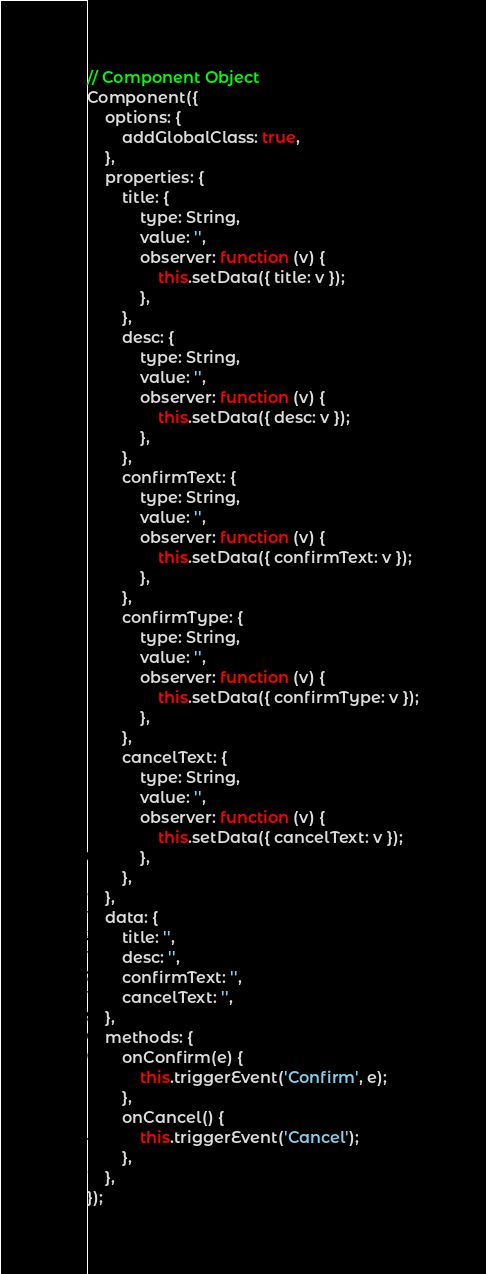<code> <loc_0><loc_0><loc_500><loc_500><_JavaScript_>// Component Object
Component({
	options: {
		addGlobalClass: true,
	},
	properties: {
		title: {
			type: String,
			value: '',
			observer: function (v) {
				this.setData({ title: v });
			},
		},
		desc: {
			type: String,
			value: '',
			observer: function (v) {
				this.setData({ desc: v });
			},
		},
		confirmText: {
			type: String,
			value: '',
			observer: function (v) {
				this.setData({ confirmText: v });
			},
		},
		confirmType: {
			type: String,
			value: '',
			observer: function (v) {
				this.setData({ confirmType: v });
			},
		},
		cancelText: {
			type: String,
			value: '',
			observer: function (v) {
				this.setData({ cancelText: v });
			},
		},
	},
	data: {
		title: '',
		desc: '',
		confirmText: '',
		cancelText: '',
	},
	methods: {
		onConfirm(e) {
			this.triggerEvent('Confirm', e);
		},
		onCancel() {
			this.triggerEvent('Cancel');
		},
	},
});
</code> 